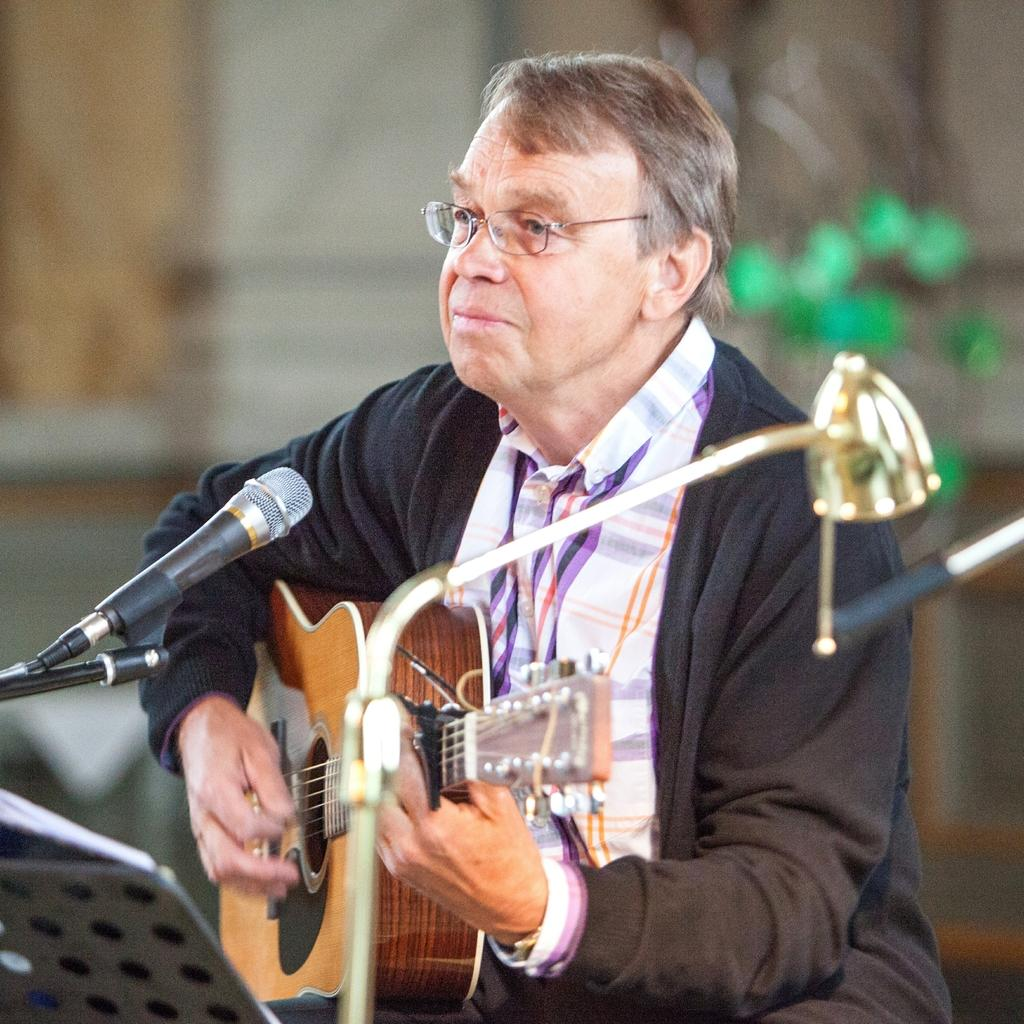Who is the main subject in the image? There is a man in the image. What is the man wearing? The man is wearing a black jacket. What is the man doing in the image? The man is playing a guitar. What object is in front of the man? There is a microphone in front of the man. What accessory is the man wearing? The man is wearing spectacles. What type of ship can be seen in the background of the image? There is no ship present in the image; it features a man playing a guitar with a microphone in front of him. What base is the man standing on in the image? The image does not show the man standing on a base; he is simply standing on the ground or a surface. 